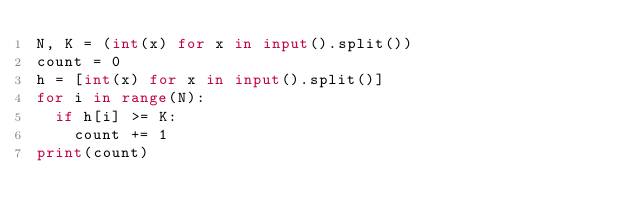<code> <loc_0><loc_0><loc_500><loc_500><_Python_>N, K = (int(x) for x in input().split())
count = 0
h = [int(x) for x in input().split()]
for i in range(N):
  if h[i] >= K:
    count += 1
print(count)</code> 